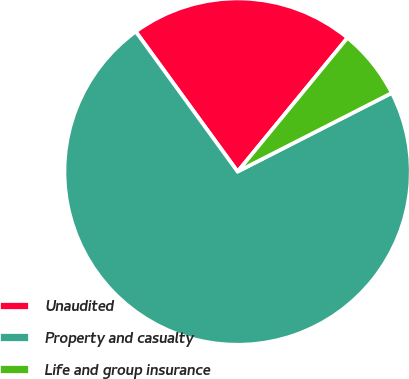Convert chart to OTSL. <chart><loc_0><loc_0><loc_500><loc_500><pie_chart><fcel>Unaudited<fcel>Property and casualty<fcel>Life and group insurance<nl><fcel>20.95%<fcel>72.5%<fcel>6.55%<nl></chart> 